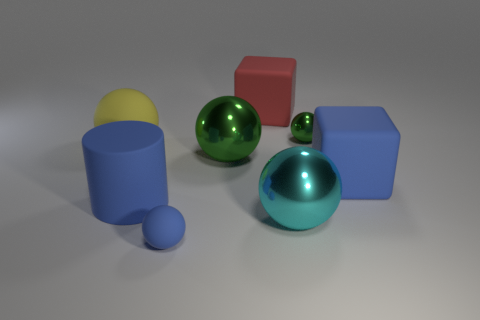What can you tell me about the lighting in this scene? The lighting in the scene seems to be coming from the top, slightly favoring the left side, which creates soft shadows on the right sides of the shapes. The light source allows the colors of the objects to be clearly distinguished and contributes to the reflective qualities of the metallic spheres. The overall lighting provides a calm and balanced atmosphere.  Do the shadows tell us anything about the positioning of the light source? Yes, by observing the direction and length of the shadows, we can deduce that the light source is positioned above and to the left of the scene. The shadows are elongated towards the right and slightly towards us, which indicates that the light is not directly overhead but at an angle. 